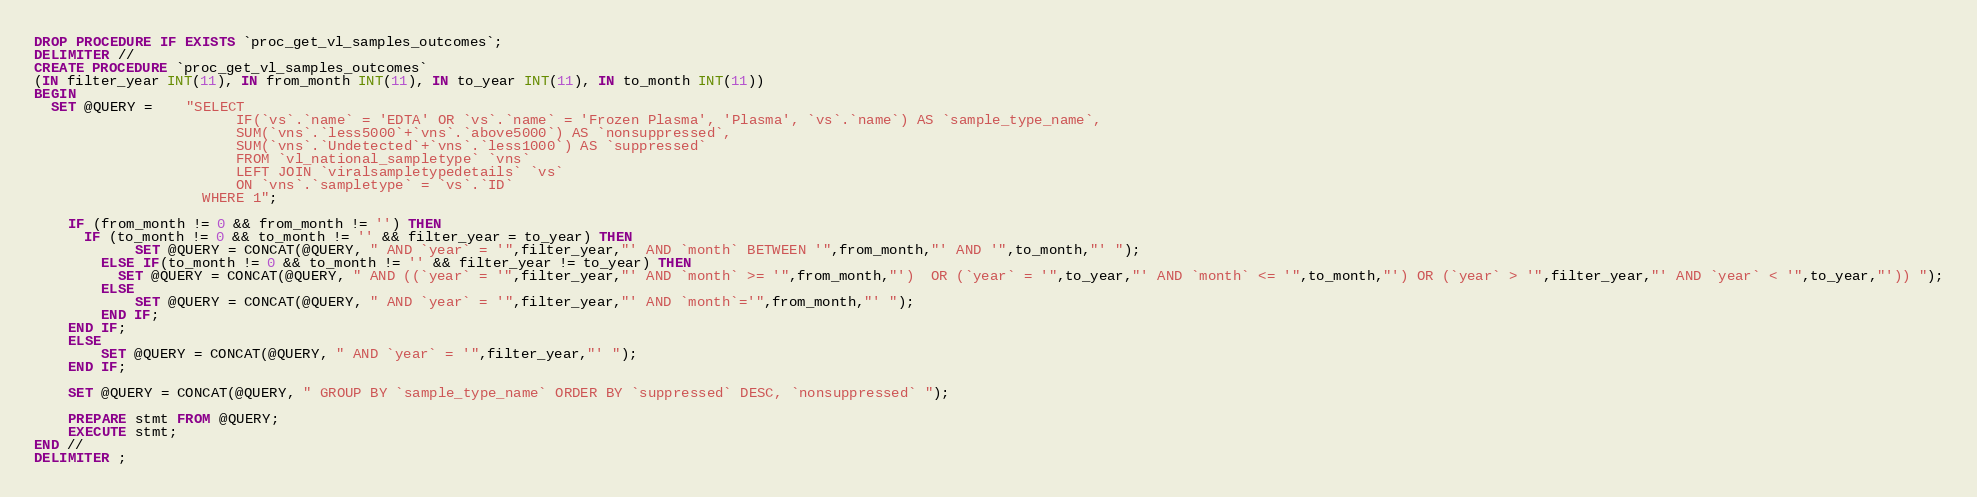Convert code to text. <code><loc_0><loc_0><loc_500><loc_500><_SQL_>DROP PROCEDURE IF EXISTS `proc_get_vl_samples_outcomes`;
DELIMITER //
CREATE PROCEDURE `proc_get_vl_samples_outcomes`
(IN filter_year INT(11), IN from_month INT(11), IN to_year INT(11), IN to_month INT(11))
BEGIN
  SET @QUERY =    "SELECT 
						IF(`vs`.`name` = 'EDTA' OR `vs`.`name` = 'Frozen Plasma', 'Plasma', `vs`.`name`) AS `sample_type_name`, 
						SUM(`vns`.`less5000`+`vns`.`above5000`) AS `nonsuppressed`, 
						SUM(`vns`.`Undetected`+`vns`.`less1000`) AS `suppressed` 
						FROM `vl_national_sampletype` `vns`
						LEFT JOIN `viralsampletypedetails` `vs` 
						ON `vns`.`sampletype` = `vs`.`ID`
					WHERE 1";

    IF (from_month != 0 && from_month != '') THEN
      IF (to_month != 0 && to_month != '' && filter_year = to_year) THEN
            SET @QUERY = CONCAT(@QUERY, " AND `year` = '",filter_year,"' AND `month` BETWEEN '",from_month,"' AND '",to_month,"' ");
        ELSE IF(to_month != 0 && to_month != '' && filter_year != to_year) THEN
          SET @QUERY = CONCAT(@QUERY, " AND ((`year` = '",filter_year,"' AND `month` >= '",from_month,"')  OR (`year` = '",to_year,"' AND `month` <= '",to_month,"') OR (`year` > '",filter_year,"' AND `year` < '",to_year,"')) ");
        ELSE
            SET @QUERY = CONCAT(@QUERY, " AND `year` = '",filter_year,"' AND `month`='",from_month,"' ");
        END IF;
    END IF;
    ELSE
        SET @QUERY = CONCAT(@QUERY, " AND `year` = '",filter_year,"' ");
    END IF;

    SET @QUERY = CONCAT(@QUERY, " GROUP BY `sample_type_name` ORDER BY `suppressed` DESC, `nonsuppressed` ");
    
    PREPARE stmt FROM @QUERY;
    EXECUTE stmt;
END //
DELIMITER ;
</code> 